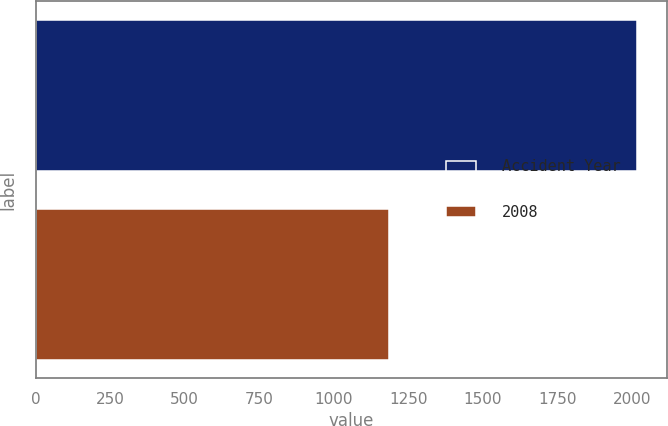Convert chart. <chart><loc_0><loc_0><loc_500><loc_500><bar_chart><fcel>Accident Year<fcel>2008<nl><fcel>2016<fcel>1184<nl></chart> 